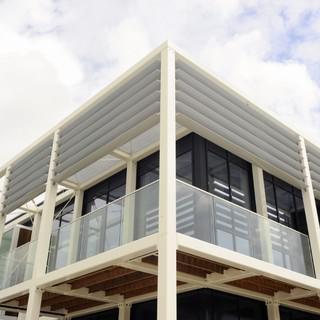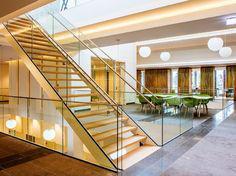The first image is the image on the left, the second image is the image on the right. Analyze the images presented: Is the assertion "The left image is an upward view of a white-framed balcony with glass panels instead of rails in front of paned glass windows." valid? Answer yes or no. Yes. The first image is the image on the left, the second image is the image on the right. For the images shown, is this caption "The left image features the exterior of a building and the right image features the interior of a building." true? Answer yes or no. Yes. 